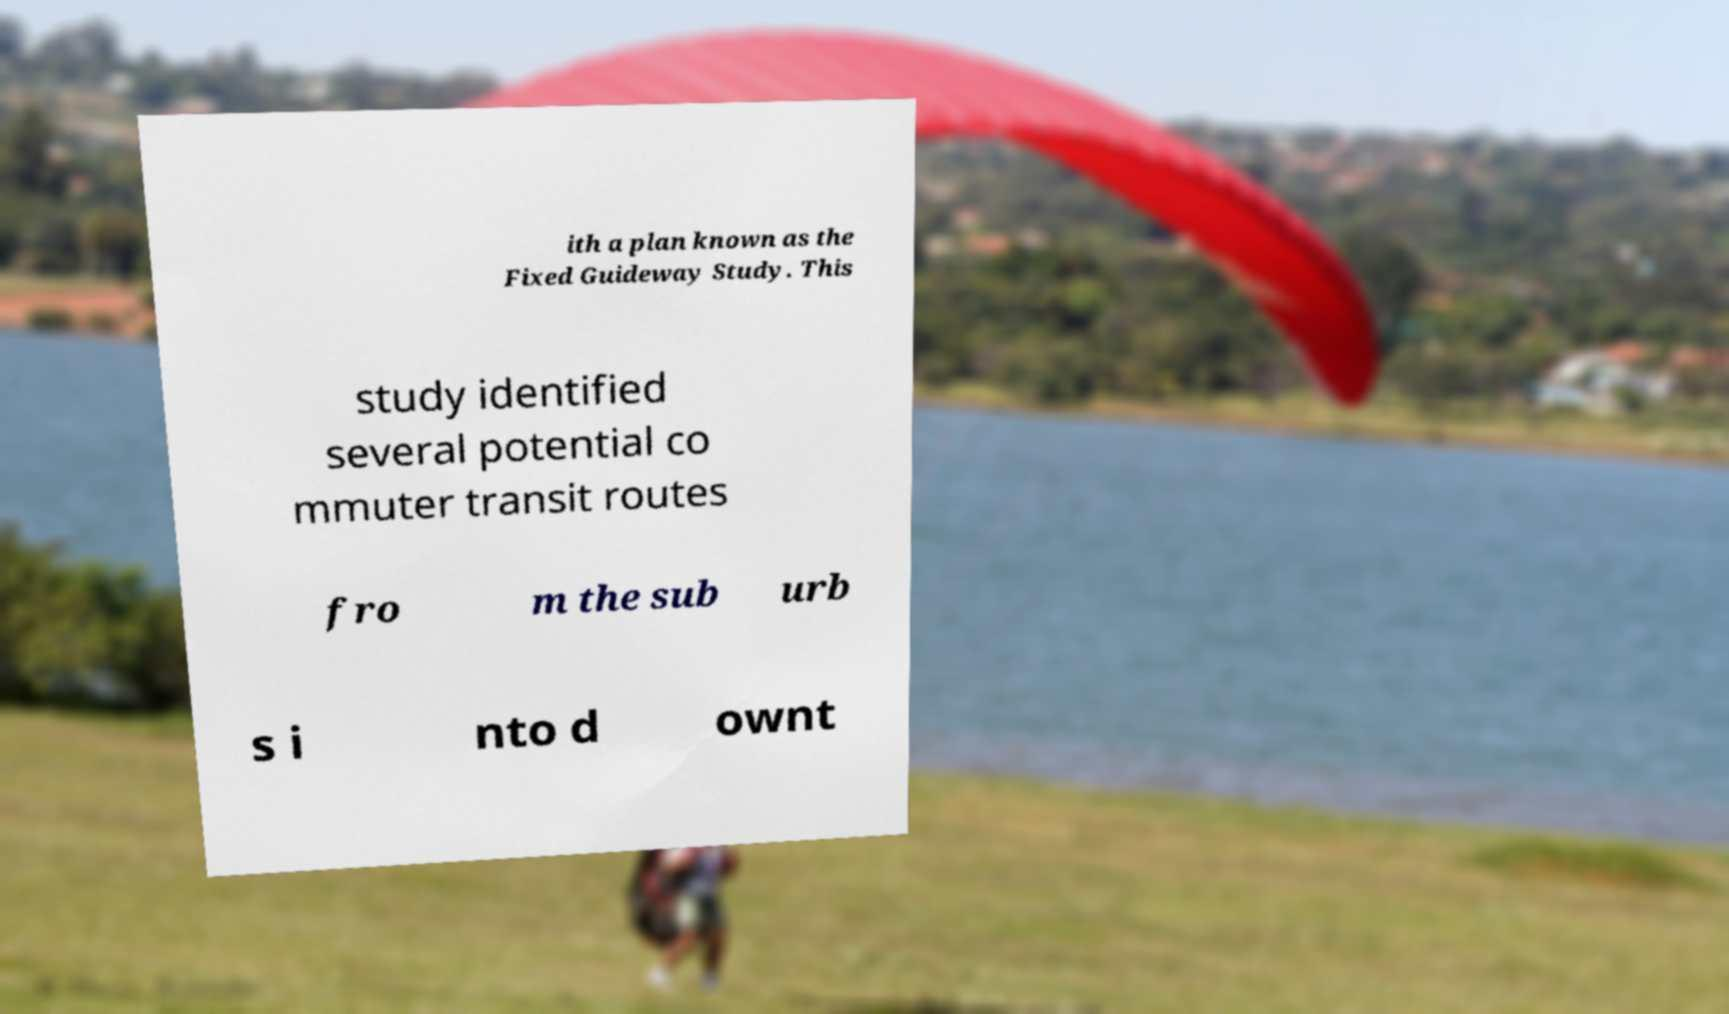Please identify and transcribe the text found in this image. ith a plan known as the Fixed Guideway Study. This study identified several potential co mmuter transit routes fro m the sub urb s i nto d ownt 